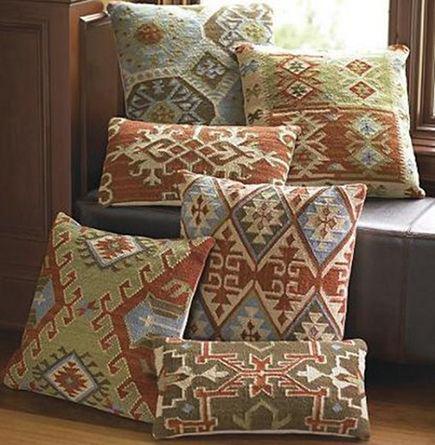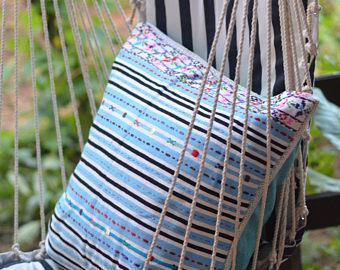The first image is the image on the left, the second image is the image on the right. Evaluate the accuracy of this statement regarding the images: "In at least one image there is only a single pillow standing up with some triangle patterns sewn into it.". Is it true? Answer yes or no. No. 